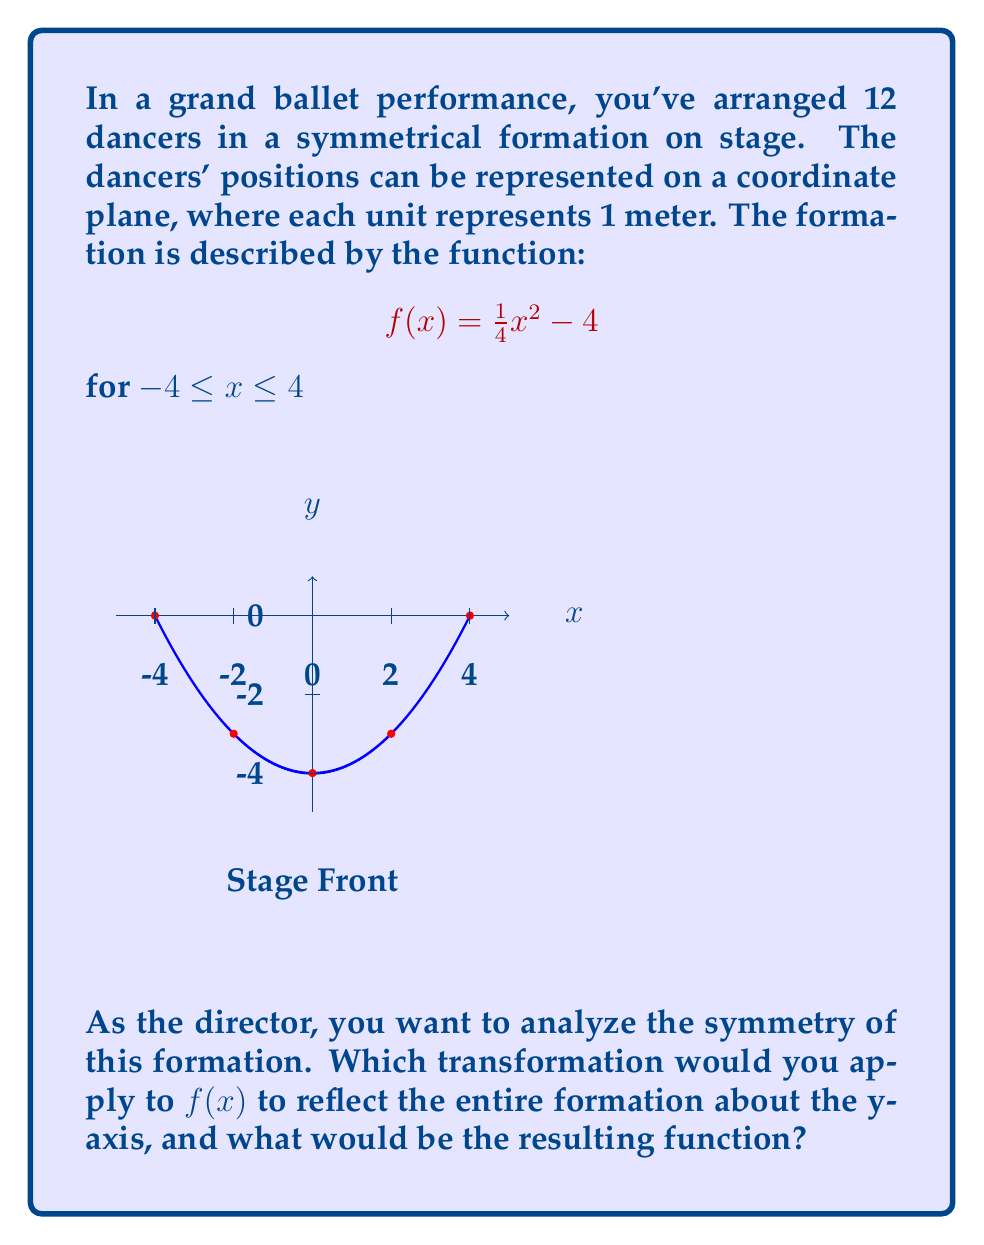What is the answer to this math problem? Let's approach this step-by-step:

1) The current function $f(x) = \frac{1}{4}x^2 - 4$ represents a parabola opening upwards with vertex at (0, -4).

2) To reflect a function about the y-axis, we replace every x with -x in the original function. This is because points (x, y) become (-x, y) when reflected about the y-axis.

3) Let's call our new function g(x). We replace x with -x in f(x):

   $g(x) = \frac{1}{4}(-x)^2 - 4$

4) Simplify:
   $g(x) = \frac{1}{4}(x^2) - 4$
   
   $g(x) = \frac{1}{4}x^2 - 4$

5) We can see that $g(x) = f(x)$. This means the function is symmetric about the y-axis.

6) In terms of the ballet formation, this means that the dancers on the left side of the stage mirror the positions of those on the right side, creating a perfectly balanced and symmetrical arrangement.

Therefore, reflecting $f(x)$ about the y-axis results in the same function, demonstrating that the original formation is already symmetrical about the y-axis.
Answer: $g(x) = f(-x) = \frac{1}{4}x^2 - 4$ 